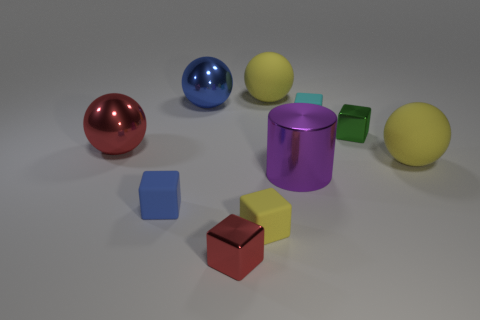Is the number of purple cylinders behind the large blue shiny thing the same as the number of yellow balls behind the large red metal ball?
Keep it short and to the point. No. How many cubes are right of the large cylinder?
Offer a terse response. 2. What number of objects are big blue things or tiny cyan metallic spheres?
Offer a very short reply. 1. What number of yellow matte things have the same size as the cylinder?
Your answer should be very brief. 2. There is a big matte object behind the big yellow rubber thing in front of the big blue metallic thing; what shape is it?
Provide a succinct answer. Sphere. Are there fewer tiny green blocks than tiny cyan cylinders?
Your response must be concise. No. There is a small metallic thing in front of the green cube; what color is it?
Make the answer very short. Red. There is a yellow thing that is both behind the blue rubber block and on the left side of the small cyan rubber cube; what material is it made of?
Provide a short and direct response. Rubber. The green thing that is made of the same material as the large red ball is what shape?
Keep it short and to the point. Cube. There is a large metallic object on the left side of the big blue thing; how many rubber balls are to the right of it?
Ensure brevity in your answer.  2. 